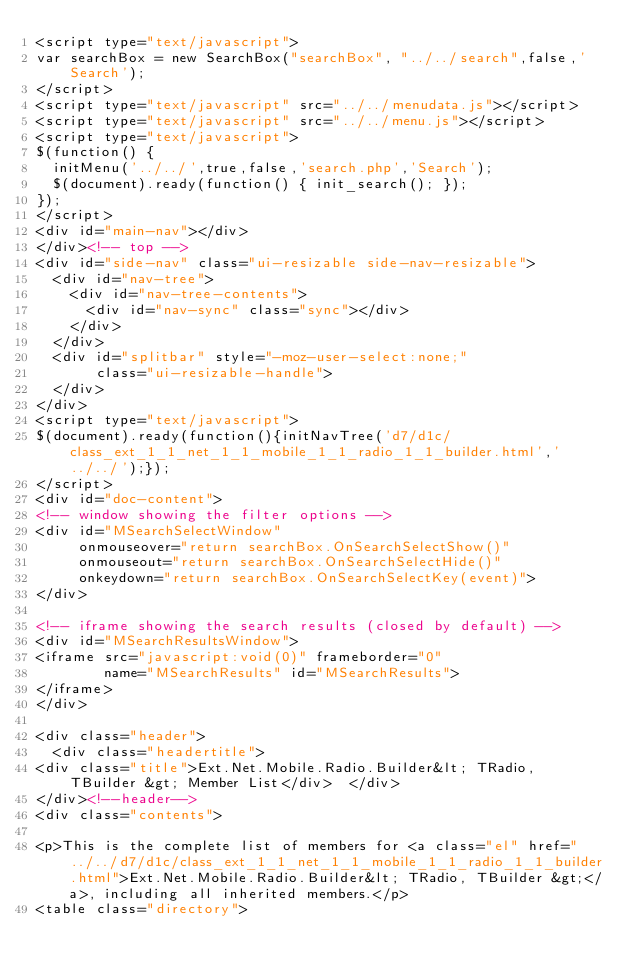Convert code to text. <code><loc_0><loc_0><loc_500><loc_500><_HTML_><script type="text/javascript">
var searchBox = new SearchBox("searchBox", "../../search",false,'Search');
</script>
<script type="text/javascript" src="../../menudata.js"></script>
<script type="text/javascript" src="../../menu.js"></script>
<script type="text/javascript">
$(function() {
  initMenu('../../',true,false,'search.php','Search');
  $(document).ready(function() { init_search(); });
});
</script>
<div id="main-nav"></div>
</div><!-- top -->
<div id="side-nav" class="ui-resizable side-nav-resizable">
  <div id="nav-tree">
    <div id="nav-tree-contents">
      <div id="nav-sync" class="sync"></div>
    </div>
  </div>
  <div id="splitbar" style="-moz-user-select:none;" 
       class="ui-resizable-handle">
  </div>
</div>
<script type="text/javascript">
$(document).ready(function(){initNavTree('d7/d1c/class_ext_1_1_net_1_1_mobile_1_1_radio_1_1_builder.html','../../');});
</script>
<div id="doc-content">
<!-- window showing the filter options -->
<div id="MSearchSelectWindow"
     onmouseover="return searchBox.OnSearchSelectShow()"
     onmouseout="return searchBox.OnSearchSelectHide()"
     onkeydown="return searchBox.OnSearchSelectKey(event)">
</div>

<!-- iframe showing the search results (closed by default) -->
<div id="MSearchResultsWindow">
<iframe src="javascript:void(0)" frameborder="0" 
        name="MSearchResults" id="MSearchResults">
</iframe>
</div>

<div class="header">
  <div class="headertitle">
<div class="title">Ext.Net.Mobile.Radio.Builder&lt; TRadio, TBuilder &gt; Member List</div>  </div>
</div><!--header-->
<div class="contents">

<p>This is the complete list of members for <a class="el" href="../../d7/d1c/class_ext_1_1_net_1_1_mobile_1_1_radio_1_1_builder.html">Ext.Net.Mobile.Radio.Builder&lt; TRadio, TBuilder &gt;</a>, including all inherited members.</p>
<table class="directory"></code> 